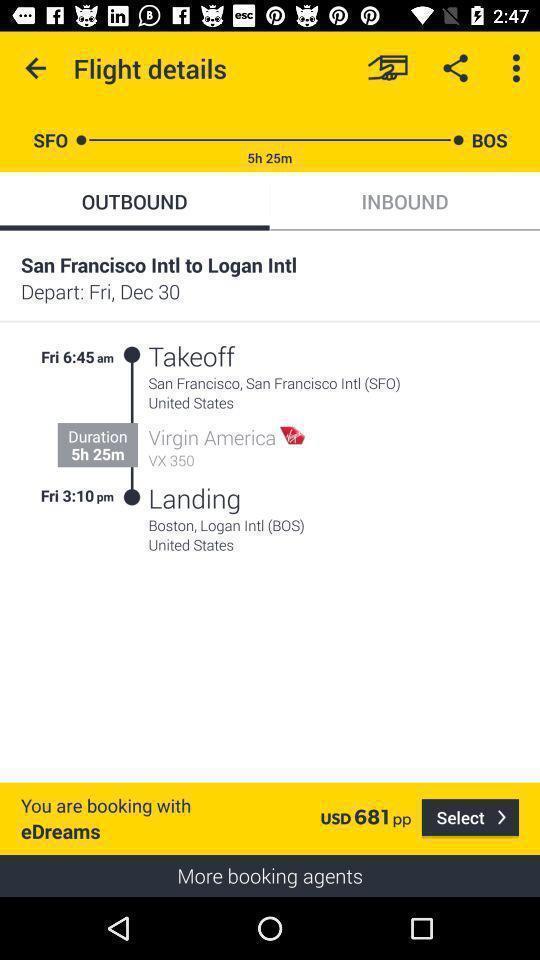Provide a detailed account of this screenshot. Page displaying the information of flight takeoff and landing. 